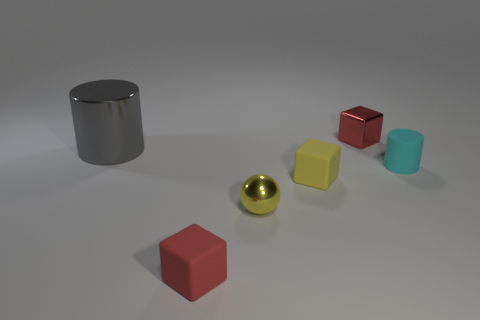Which object in the image appears to be the heaviest? Judging by the size and assumed material, the large gray cylinder on the left seems like it would be the heaviest object. 